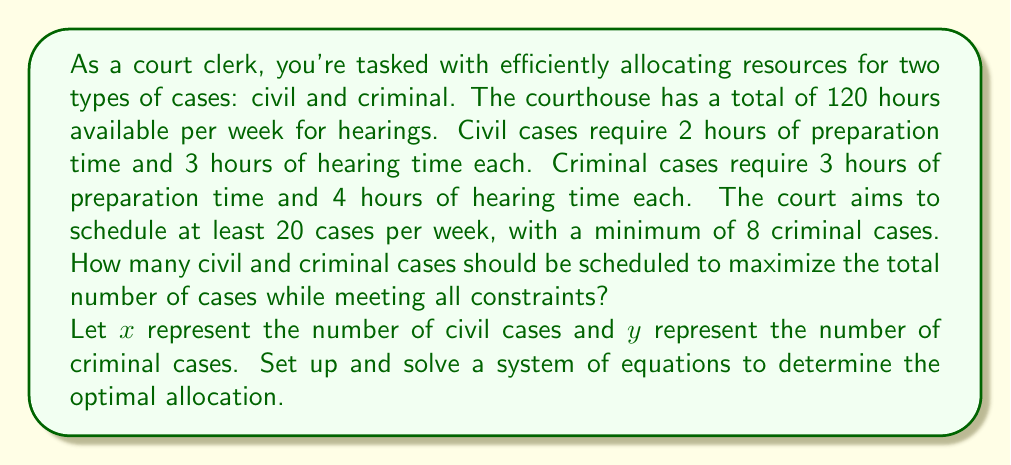Help me with this question. Let's approach this step-by-step:

1) First, let's set up our constraints:

   a) Total time constraint:
      Civil cases: $2x + 3x = 5x$ hours
      Criminal cases: $3y + 4y = 7y$ hours
      Total time: $5x + 7y \leq 120$

   b) Minimum total cases: $x + y \geq 20$

   c) Minimum criminal cases: $y \geq 8$

   d) Non-negativity: $x \geq 0$ and $y \geq 0$

2) Our objective is to maximize $x + y$ subject to these constraints.

3) From the minimum criminal cases constraint, we know $y = 8$ is our starting point.

4) Substituting this into the total time constraint:
   $5x + 7(8) \leq 120$
   $5x + 56 \leq 120$
   $5x \leq 64$
   $x \leq 12.8$

5) Since $x$ must be an integer, the maximum value it can take is 12.

6) Let's verify if this satisfies all constraints:
   - Total time: $5(12) + 7(8) = 60 + 56 = 116 \leq 120$
   - Total cases: $12 + 8 = 20 \geq 20$
   - Criminal cases: $8 \geq 8$

7) This solution satisfies all constraints and maximizes the total number of cases.
Answer: The optimal allocation is 12 civil cases and 8 criminal cases, for a total of 20 cases. 